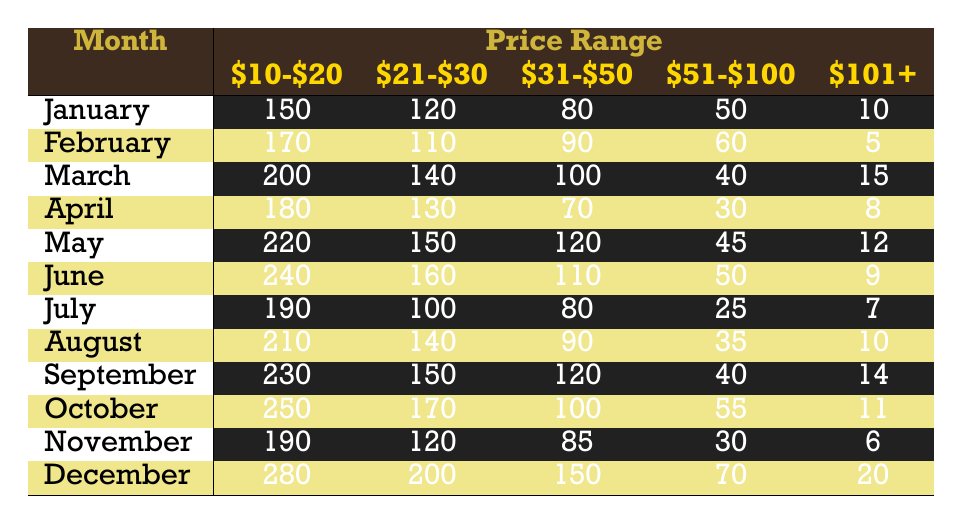What was the total number of grunge records sold in December? To find the total records sold in December, add up all the sales across the price ranges: 280 (for $10-$20) + 200 (for $21-$30) + 150 (for $31-$50) + 70 (for $51-$100) + 20 (for $101+) = 720.
Answer: 720 Which price range had the highest sales in March? In March, the sales figures for each price range are: $10-$20: 200, $21-$30: 140, $31-$50: 100, $51-$100: 40, $101+: 15. The highest sales occurred in the $10-$20 range with 200 records sold.
Answer: $10-$20 What is the average number of records sold in the $51-$100 price range over the year? Total sales in the $51-$100 range for the year are: 50 (January) + 60 (February) + 40 (March) + 30 (April) + 45 (May) + 50 (June) + 25 (July) + 35 (August) + 40 (September) + 55 (October) + 30 (November) + 70 (December) = 650. There are 12 months, so the average is 650/12 ≈ 54.17.
Answer: 54.17 Was there a month where sales in the $101+ range exceeded 15 records? Looking at the $101+ sales figures: January: 10, February: 5, March: 15, April: 8, May: 12, June: 9, July: 7, August: 10, September: 14, October: 11, November: 6, December: 20. December is the only month where sales exceeded 15, with 20 records sold.
Answer: Yes What is the trend in sales for the $10-$20 price range from January to December? Checking the monthly data: January: 150, February: 170, March: 200, April: 180, May: 220, June: 240, July: 190, August: 210, September: 230, October: 250, November: 190, December: 280. The trend shows an overall increase, especially peaking in June and December.
Answer: Increasing Which price range had the lowest sales in November? In November, the sales figures were: $10-$20: 190, $21-$30: 120, $31-$50: 85, $51-$100: 30, $101+: 6. The lowest was in the $101+ range with 6 records sold.
Answer: $101+ What is the difference in sales between the highest month and the lowest month for the $21-$30 range? The data shows the highest sales for the $21-$30 range in December (200) and the lowest in February (110). The difference is 200 - 110 = 90.
Answer: 90 During which month did sales in the $31-$50 range experience the least amount? The sales for the $31-$50 range were: January: 80, February: 90, March: 100, April: 70, May: 120, June: 110, July: 80, August: 90, September: 120, October: 100, November: 85, December: 150. The least sales occurred in April, with 70 records sold.
Answer: April How many records were sold in the $10-$20 range from June to November? Calculating the sales from June to November: June: 240, July: 190, August: 210, September: 230, October: 250, November: 190. The total is 240 + 190 + 210 + 230 + 250 + 190 = 1390.
Answer: 1390 